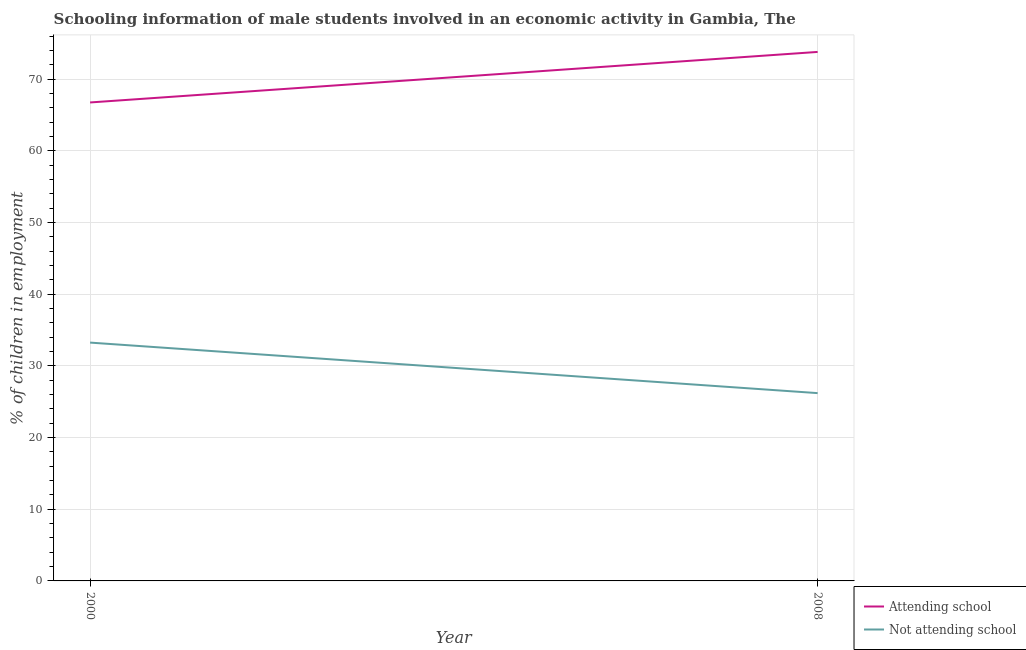How many different coloured lines are there?
Ensure brevity in your answer.  2. Does the line corresponding to percentage of employed males who are not attending school intersect with the line corresponding to percentage of employed males who are attending school?
Make the answer very short. No. Is the number of lines equal to the number of legend labels?
Give a very brief answer. Yes. What is the percentage of employed males who are attending school in 2008?
Keep it short and to the point. 73.8. Across all years, what is the maximum percentage of employed males who are not attending school?
Keep it short and to the point. 33.25. Across all years, what is the minimum percentage of employed males who are attending school?
Provide a short and direct response. 66.75. What is the total percentage of employed males who are not attending school in the graph?
Offer a very short reply. 59.45. What is the difference between the percentage of employed males who are attending school in 2000 and that in 2008?
Offer a very short reply. -7.05. What is the difference between the percentage of employed males who are attending school in 2008 and the percentage of employed males who are not attending school in 2000?
Keep it short and to the point. 40.55. What is the average percentage of employed males who are attending school per year?
Give a very brief answer. 70.28. In the year 2000, what is the difference between the percentage of employed males who are not attending school and percentage of employed males who are attending school?
Offer a terse response. -33.5. In how many years, is the percentage of employed males who are attending school greater than 58 %?
Offer a very short reply. 2. What is the ratio of the percentage of employed males who are attending school in 2000 to that in 2008?
Your answer should be compact. 0.9. In how many years, is the percentage of employed males who are not attending school greater than the average percentage of employed males who are not attending school taken over all years?
Your response must be concise. 1. Does the percentage of employed males who are attending school monotonically increase over the years?
Give a very brief answer. Yes. Is the percentage of employed males who are attending school strictly greater than the percentage of employed males who are not attending school over the years?
Your answer should be compact. Yes. Is the percentage of employed males who are not attending school strictly less than the percentage of employed males who are attending school over the years?
Your response must be concise. Yes. How many lines are there?
Offer a terse response. 2. What is the difference between two consecutive major ticks on the Y-axis?
Your answer should be very brief. 10. Are the values on the major ticks of Y-axis written in scientific E-notation?
Your answer should be very brief. No. Does the graph contain grids?
Make the answer very short. Yes. How many legend labels are there?
Keep it short and to the point. 2. What is the title of the graph?
Keep it short and to the point. Schooling information of male students involved in an economic activity in Gambia, The. What is the label or title of the X-axis?
Provide a short and direct response. Year. What is the label or title of the Y-axis?
Your response must be concise. % of children in employment. What is the % of children in employment in Attending school in 2000?
Keep it short and to the point. 66.75. What is the % of children in employment of Not attending school in 2000?
Your answer should be very brief. 33.25. What is the % of children in employment in Attending school in 2008?
Provide a succinct answer. 73.8. What is the % of children in employment in Not attending school in 2008?
Provide a short and direct response. 26.2. Across all years, what is the maximum % of children in employment of Attending school?
Your response must be concise. 73.8. Across all years, what is the maximum % of children in employment in Not attending school?
Your response must be concise. 33.25. Across all years, what is the minimum % of children in employment in Attending school?
Keep it short and to the point. 66.75. Across all years, what is the minimum % of children in employment of Not attending school?
Make the answer very short. 26.2. What is the total % of children in employment in Attending school in the graph?
Provide a succinct answer. 140.55. What is the total % of children in employment of Not attending school in the graph?
Ensure brevity in your answer.  59.45. What is the difference between the % of children in employment in Attending school in 2000 and that in 2008?
Keep it short and to the point. -7.05. What is the difference between the % of children in employment in Not attending school in 2000 and that in 2008?
Offer a very short reply. 7.05. What is the difference between the % of children in employment of Attending school in 2000 and the % of children in employment of Not attending school in 2008?
Give a very brief answer. 40.55. What is the average % of children in employment in Attending school per year?
Your answer should be compact. 70.28. What is the average % of children in employment in Not attending school per year?
Keep it short and to the point. 29.72. In the year 2000, what is the difference between the % of children in employment in Attending school and % of children in employment in Not attending school?
Your response must be concise. 33.5. In the year 2008, what is the difference between the % of children in employment of Attending school and % of children in employment of Not attending school?
Offer a terse response. 47.6. What is the ratio of the % of children in employment of Attending school in 2000 to that in 2008?
Provide a succinct answer. 0.9. What is the ratio of the % of children in employment of Not attending school in 2000 to that in 2008?
Offer a very short reply. 1.27. What is the difference between the highest and the second highest % of children in employment of Attending school?
Your response must be concise. 7.05. What is the difference between the highest and the second highest % of children in employment in Not attending school?
Keep it short and to the point. 7.05. What is the difference between the highest and the lowest % of children in employment in Attending school?
Make the answer very short. 7.05. What is the difference between the highest and the lowest % of children in employment of Not attending school?
Your answer should be very brief. 7.05. 